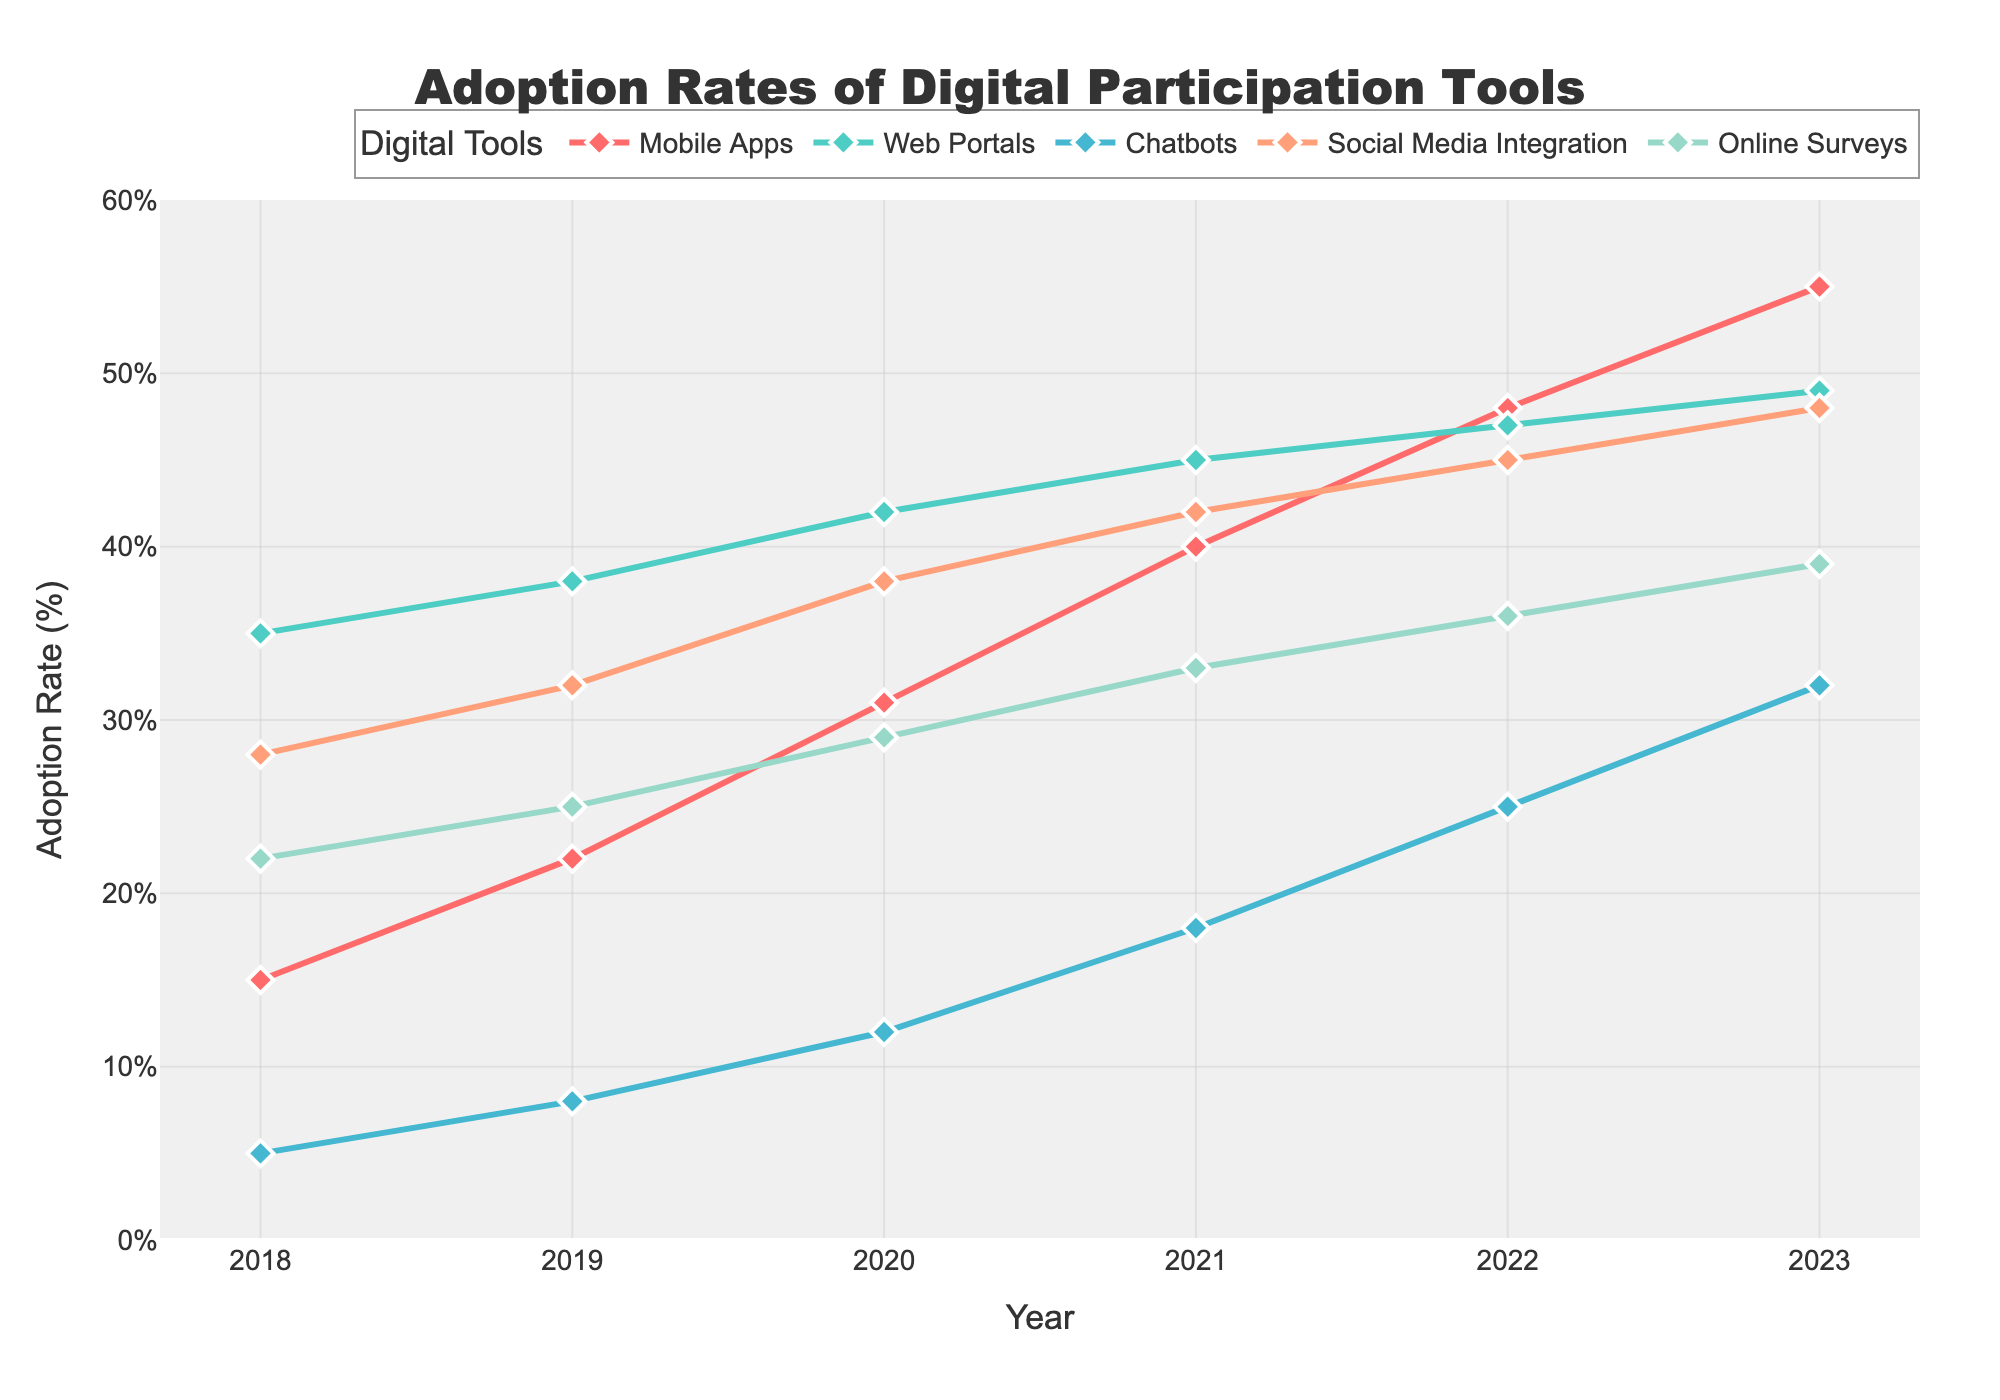What's the average adoption rate of Mobile Apps over the years? To find the average adoption rate of Mobile Apps, add the adoption rates from each year and divide by the number of years. (15 + 22 + 31 + 40 + 48 + 55) / 6 = 211 / 6 = 35.17
Answer: 35.17 Which digital participation tool had the highest adoption rate in 2023? In 2023, compare the adoption rates of all tools. Mobile Apps: 55, Web Portals: 49, Chatbots: 32, Social Media Integration: 48, Online Surveys: 39. The highest is Mobile Apps with 55%.
Answer: Mobile Apps Which tool had the lowest adoption rate in 2019? In 2019, compare the adoption rates of all tools. Mobile Apps: 22, Web Portals: 38, Chatbots: 8, Social Media Integration: 32, Online Surveys: 25. The lowest is Chatbots with 8%.
Answer: Chatbots What is the increase in adoption rate of Web Portals from 2018 to 2023? Subtract the adoption rate in 2018 from that in 2023. 49 (2023) - 35 (2018) = 14.
Answer: 14 In which year did Social Media Integration surpass Chatbots in adoption rate? Compare the adoption rates of Social Media Integration and Chatbots year by year until Social Media Integration exceeds Chatbots. In 2020, Social Media Integration (38) surpasses Chatbots (12).
Answer: 2020 By how much did the adoption rate of Online Surveys increase from 2019 to 2023? Subtract the adoption rate in 2019 from that in 2023. 39 (2023) - 25 (2019) = 14.
Answer: 14 What is the average adoption rate of Chatbots from 2020 to 2023? Add the adoption rates of Chatbots from 2020 to 2023 and divide by the number of years. (12 + 18 + 25 + 32) / 4 = 87 / 4 = 21.75
Answer: 21.75 Which tool shows the most consistent growth over the years? By observing the trend lines of all tools, Mobile Apps consistently increases each year from 2018 to 2023, indicating the most consistent growth.
Answer: Mobile Apps What is the difference between the highest and lowest adoption rates in 2022? Identify the highest and lowest adoption rates in 2022 and subtract the latter from the former. Highest: Mobile Apps (48), Lowest: Chatbots (25). 48 - 25 = 23.
Answer: 23 